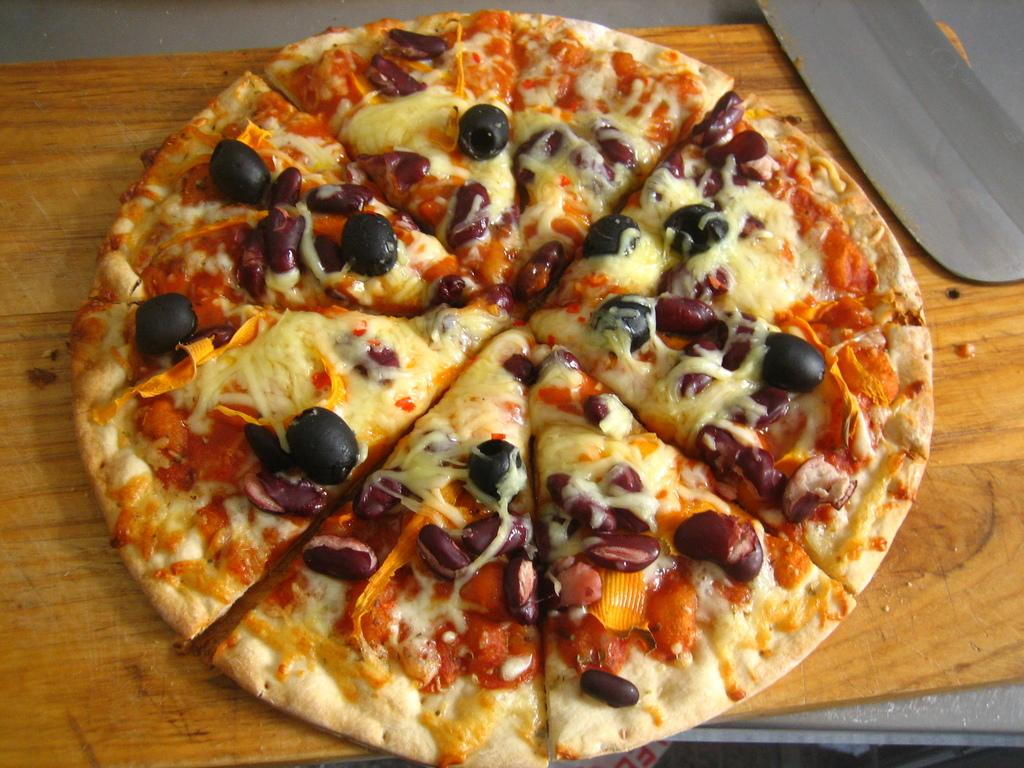What type of food is the main subject of the image? There is a pizza in the image. What is unique about the pizza's stuffing? The pizza has black grapes as stuffings. On what surface is the pizza placed? The pizza is placed on a wooden board. What utensil is visible in the image? There is a knife visible in the image. What type of worm can be seen crawling on the pizza in the image? There is no worm present on the pizza in the image. What is the pizza being used for in the image, considering the presence of glue? There is no glue present in the image, and the pizza is not being used for any specific purpose other than being a food item. 